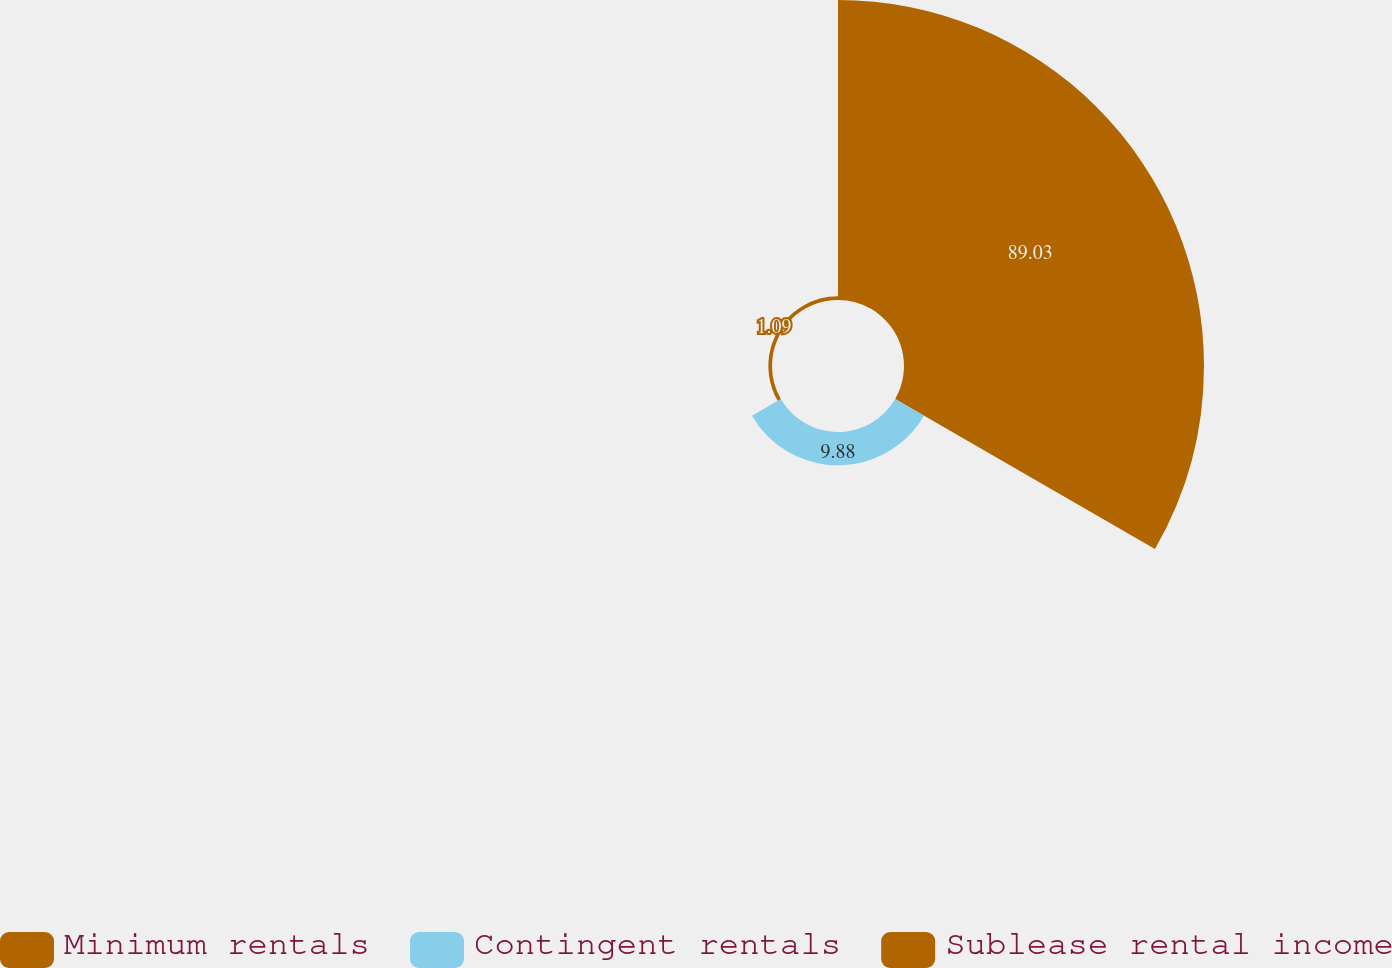Convert chart to OTSL. <chart><loc_0><loc_0><loc_500><loc_500><pie_chart><fcel>Minimum rentals<fcel>Contingent rentals<fcel>Sublease rental income<nl><fcel>89.02%<fcel>9.88%<fcel>1.09%<nl></chart> 